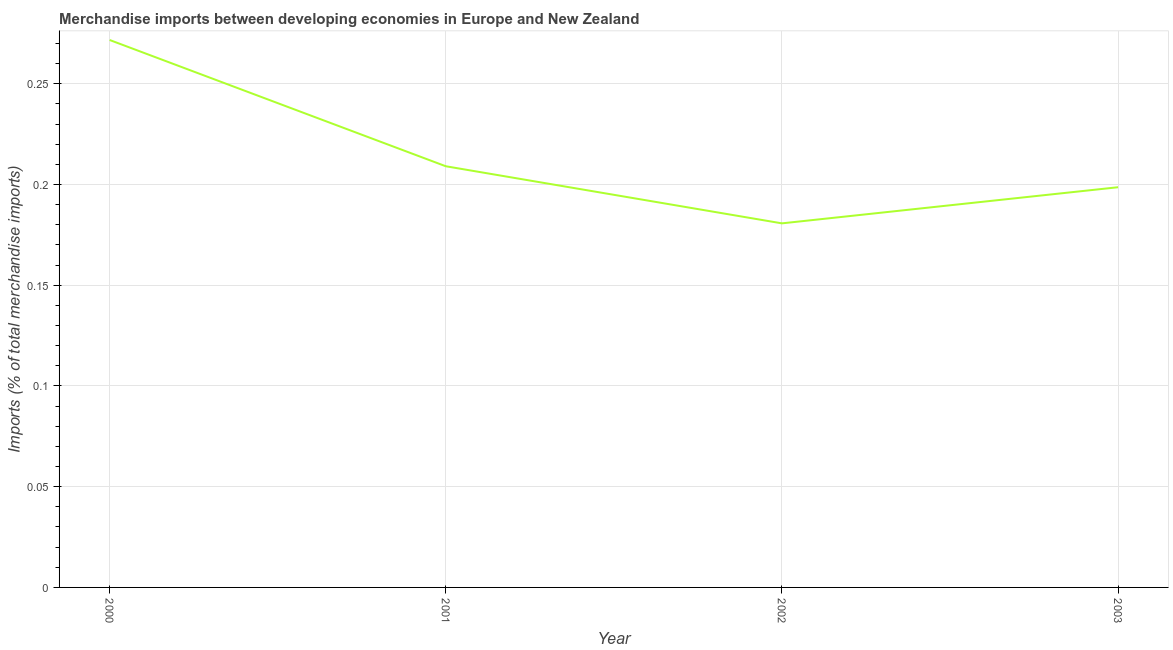What is the merchandise imports in 2001?
Provide a succinct answer. 0.21. Across all years, what is the maximum merchandise imports?
Your answer should be compact. 0.27. Across all years, what is the minimum merchandise imports?
Ensure brevity in your answer.  0.18. In which year was the merchandise imports maximum?
Provide a succinct answer. 2000. What is the sum of the merchandise imports?
Provide a short and direct response. 0.86. What is the difference between the merchandise imports in 2002 and 2003?
Your response must be concise. -0.02. What is the average merchandise imports per year?
Provide a succinct answer. 0.22. What is the median merchandise imports?
Your response must be concise. 0.2. What is the ratio of the merchandise imports in 2001 to that in 2002?
Offer a terse response. 1.16. Is the difference between the merchandise imports in 2000 and 2003 greater than the difference between any two years?
Your response must be concise. No. What is the difference between the highest and the second highest merchandise imports?
Make the answer very short. 0.06. What is the difference between the highest and the lowest merchandise imports?
Provide a short and direct response. 0.09. In how many years, is the merchandise imports greater than the average merchandise imports taken over all years?
Keep it short and to the point. 1. Are the values on the major ticks of Y-axis written in scientific E-notation?
Offer a terse response. No. Does the graph contain grids?
Your response must be concise. Yes. What is the title of the graph?
Provide a short and direct response. Merchandise imports between developing economies in Europe and New Zealand. What is the label or title of the Y-axis?
Provide a succinct answer. Imports (% of total merchandise imports). What is the Imports (% of total merchandise imports) of 2000?
Give a very brief answer. 0.27. What is the Imports (% of total merchandise imports) of 2001?
Your response must be concise. 0.21. What is the Imports (% of total merchandise imports) of 2002?
Give a very brief answer. 0.18. What is the Imports (% of total merchandise imports) in 2003?
Keep it short and to the point. 0.2. What is the difference between the Imports (% of total merchandise imports) in 2000 and 2001?
Offer a very short reply. 0.06. What is the difference between the Imports (% of total merchandise imports) in 2000 and 2002?
Give a very brief answer. 0.09. What is the difference between the Imports (% of total merchandise imports) in 2000 and 2003?
Make the answer very short. 0.07. What is the difference between the Imports (% of total merchandise imports) in 2001 and 2002?
Ensure brevity in your answer.  0.03. What is the difference between the Imports (% of total merchandise imports) in 2001 and 2003?
Ensure brevity in your answer.  0.01. What is the difference between the Imports (% of total merchandise imports) in 2002 and 2003?
Offer a very short reply. -0.02. What is the ratio of the Imports (% of total merchandise imports) in 2000 to that in 2001?
Ensure brevity in your answer.  1.3. What is the ratio of the Imports (% of total merchandise imports) in 2000 to that in 2002?
Your answer should be compact. 1.5. What is the ratio of the Imports (% of total merchandise imports) in 2000 to that in 2003?
Ensure brevity in your answer.  1.37. What is the ratio of the Imports (% of total merchandise imports) in 2001 to that in 2002?
Your answer should be compact. 1.16. What is the ratio of the Imports (% of total merchandise imports) in 2001 to that in 2003?
Your response must be concise. 1.05. What is the ratio of the Imports (% of total merchandise imports) in 2002 to that in 2003?
Keep it short and to the point. 0.91. 